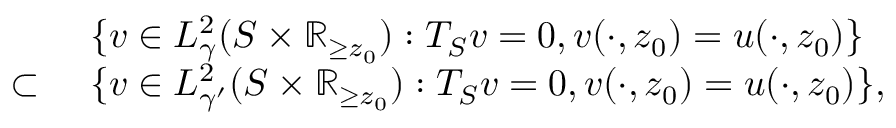<formula> <loc_0><loc_0><loc_500><loc_500>\begin{array} { r l } & { \ \{ v \in L _ { \gamma } ^ { 2 } ( S \times \mathbb { R } _ { \geq z _ { 0 } } ) \colon T _ { S } v = 0 , v ( \cdot , z _ { 0 } ) = u ( \cdot , z _ { 0 } ) \} } \\ { \subset } & { \ \{ v \in L _ { \gamma ^ { \prime } } ^ { 2 } ( S \times \mathbb { R } _ { \geq z _ { 0 } } ) \colon T _ { S } v = 0 , v ( \cdot , z _ { 0 } ) = u ( \cdot , z _ { 0 } ) \} , } \end{array}</formula> 